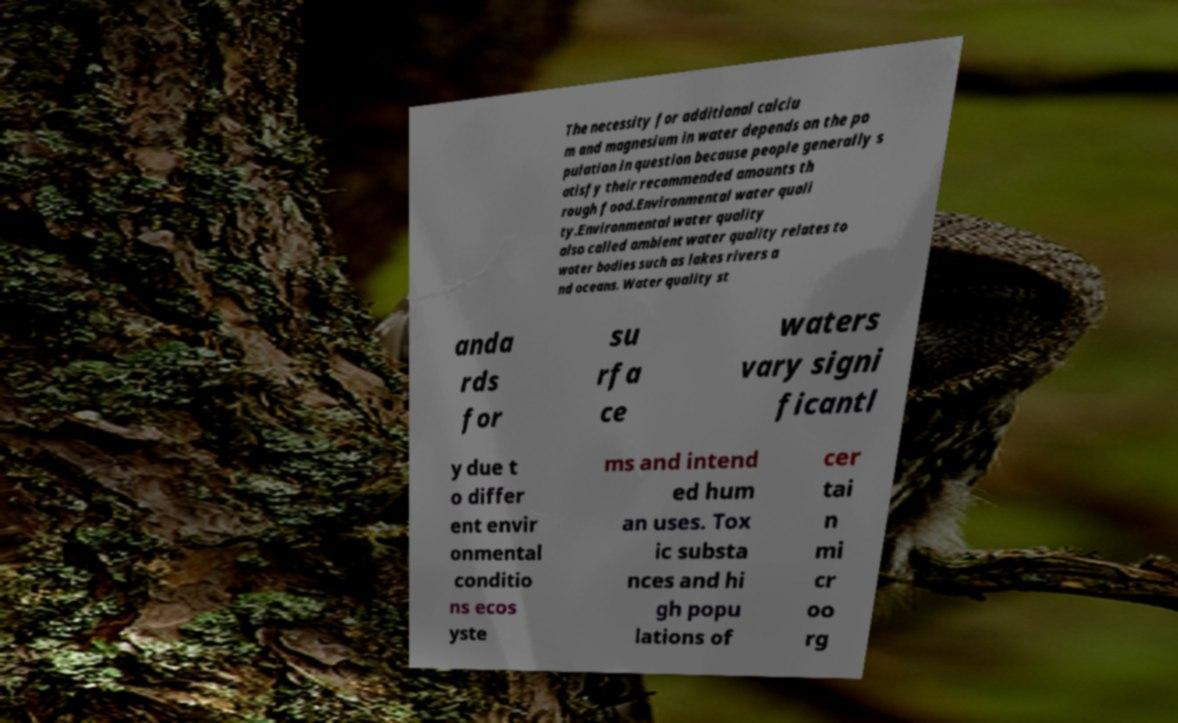There's text embedded in this image that I need extracted. Can you transcribe it verbatim? The necessity for additional calciu m and magnesium in water depends on the po pulation in question because people generally s atisfy their recommended amounts th rough food.Environmental water quali ty.Environmental water quality also called ambient water quality relates to water bodies such as lakes rivers a nd oceans. Water quality st anda rds for su rfa ce waters vary signi ficantl y due t o differ ent envir onmental conditio ns ecos yste ms and intend ed hum an uses. Tox ic substa nces and hi gh popu lations of cer tai n mi cr oo rg 